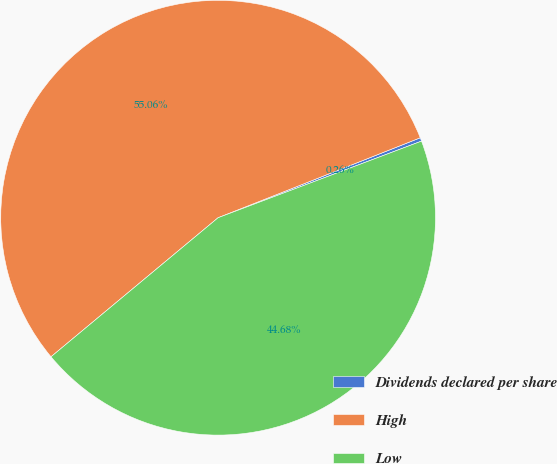Convert chart. <chart><loc_0><loc_0><loc_500><loc_500><pie_chart><fcel>Dividends declared per share<fcel>High<fcel>Low<nl><fcel>0.26%<fcel>55.05%<fcel>44.68%<nl></chart> 